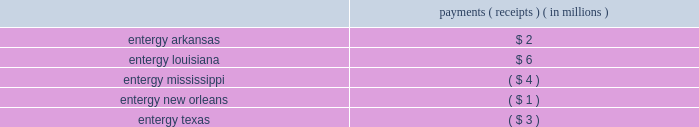Entergy corporation and subsidiaries notes to financial statements the ferc proceedings that resulted from rate filings made in 2007 , 2008 , and 2009 have been resolved by various orders issued by the ferc and appellate courts .
See below for a discussion of rate filings since 2009 and the comprehensive recalculation filing directed by the ferc in the proceeding related to the 2010 rate filing .
2010 rate filing based on calendar year 2009 production costs in may 2010 , entergy filed with the ferc the 2010 rates in accordance with the ferc 2019s orders in the system agreement proceeding , and supplemented the filing in september 2010 .
Several parties intervened in the proceeding at the ferc , including the lpsc and the city council , which also filed protests .
In july 2010 the ferc accepted entergy 2019s proposed rates for filing , effective june 1 , 2010 , subject to refund , and set the proceeding for hearing and settlement procedures .
Settlement procedures have been terminated , and the alj scheduled hearings to begin in march 2011 .
Subsequently , in january 2011 the alj issued an order directing the parties and ferc staff to show cause why this proceeding should not be stayed pending the issuance of ferc decisions in the prior production cost proceedings currently before the ferc on review .
In march 2011 the alj issued an order placing this proceeding in abeyance .
In october 2013 the ferc issued an order granting clarification and denying rehearing with respect to its october 2011 rehearing order in this proceeding .
The ferc clarified that in a bandwidth proceeding parties can challenge erroneous inputs , implementation errors , or prudence of cost inputs , but challenges to the bandwidth formula itself must be raised in a federal power act section 206 complaint or section 205 filing .
Subsequently in october 2013 the presiding alj lifted the stay order holding in abeyance the hearing previously ordered by the ferc and directing that the remaining issues proceed to a hearing on the merits .
The hearing was held in march 2014 and the presiding alj issued an initial decision in september 2014 .
Briefs on exception were filed in october 2014 .
In december 2015 the ferc issued an order affirming the initial decision in part and rejecting the initial decision in part .
Among other things , the december 2015 order directs entergy services to submit a compliance filing , the results of which may affect the rough production cost equalization filings made for the june - december 2005 , 2006 , 2007 , and 2008 test periods .
In january 2016 the lpsc , the apsc , and entergy services filed requests for rehearing of the ferc 2019s december 2015 order .
In february 2016 , entergy services submitted the compliance filing ordered in the december 2015 order .
The result of the true-up payments and receipts for the recalculation of production costs resulted in the following payments/receipts among the utility operating companies : payments ( receipts ) ( in millions ) .
2011 rate filing based on calendar year 2010 production costs in may 2011 , entergy filed with the ferc the 2011 rates in accordance with the ferc 2019s orders in the system agreement proceeding .
Several parties intervened in the proceeding at the ferc , including the lpsc , which also filed a protest .
In july 2011 the ferc accepted entergy 2019s proposed rates for filing , effective june 1 , 2011 , subject to refund , set the proceeding for hearing procedures , and then held those procedures in abeyance pending ferc decisions in the prior production cost proceedings currently before the ferc on review .
In january 2014 the lpsc filed a petition for a writ of mandamus at the united states court of appeals for the fifth circuit .
In its petition , the lpsc requested that the fifth circuit issue an order compelling the ferc to issue a final order in several proceedings related to the system agreement , including the 2011 rate filing based on calendar year 2010 production costs and the 2012 and 2013 rate filings discussed below .
In march 2014 the fifth circuit rejected the lpsc 2019s petition for a writ of mandamus .
In december 2014 the ferc rescinded its earlier abeyance order and consolidated the 2011 rate filing with the 2012 , 2013 .
What is the difference in payments between entergy louisiana and entergy mississippi , in millions? 
Computations: (6 + 4)
Answer: 10.0. 